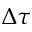<formula> <loc_0><loc_0><loc_500><loc_500>\Delta \tau</formula> 